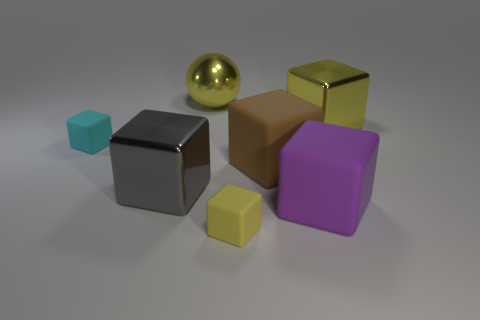What is the arrangement of the objects in relation to each other? The objects in the image are arranged on a flat surface in a somewhat scattered formation. The small cyan cube is closest to the camera on the left, followed by the silver cube. Slightly behind and to the right of these two is the larger brown cube, and there is a small yellow cube in front of the brown one, offset to the right. The large purple cube is behind the yellow and brown cubes centered towards the right side of the image, while the large yellow ball is further to the right and slightly behind the purple cube.  If I were to categorize these objects by their finish, which groups would they fall into? Based on their finish, the objects in the image could be categorized into two distinct groups. The first group consists of five cubes, all of which have a matte finish and come in various colors—cyan, silver, brown, yellow, and purple. The second group contains only one object, which is a large shiny yellow sphere with a metallic finish. 